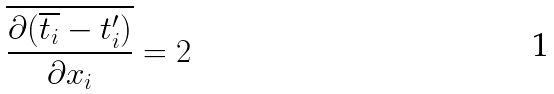Convert formula to latex. <formula><loc_0><loc_0><loc_500><loc_500>\overline { \frac { \partial ( \overline { t _ { i } } - t _ { i } ^ { \prime } ) } { \partial x _ { i } } } = 2</formula> 